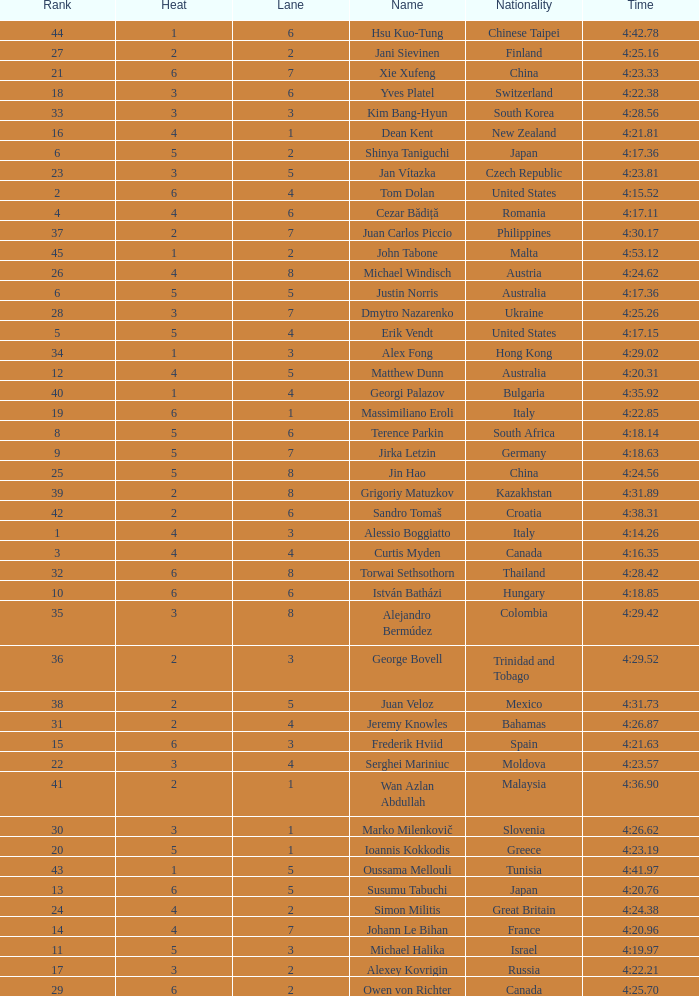Who was the 4 lane person from Canada? 4.0. 